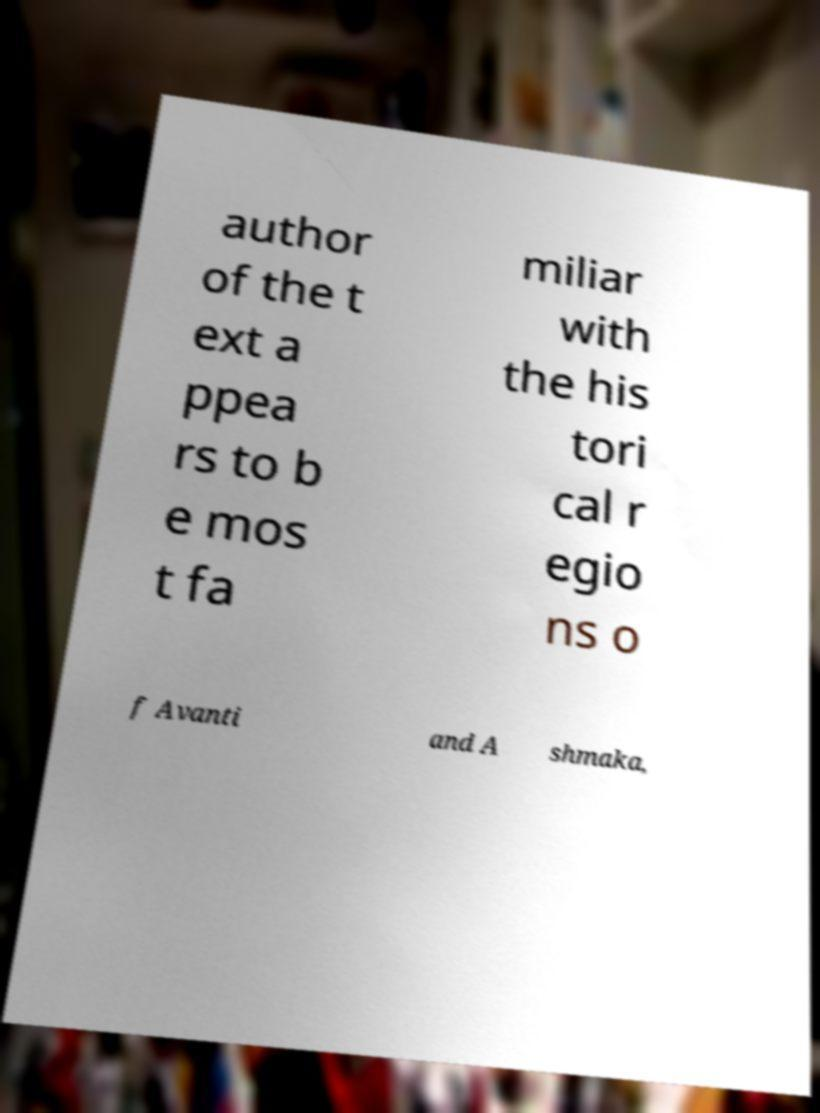Can you accurately transcribe the text from the provided image for me? author of the t ext a ppea rs to b e mos t fa miliar with the his tori cal r egio ns o f Avanti and A shmaka, 